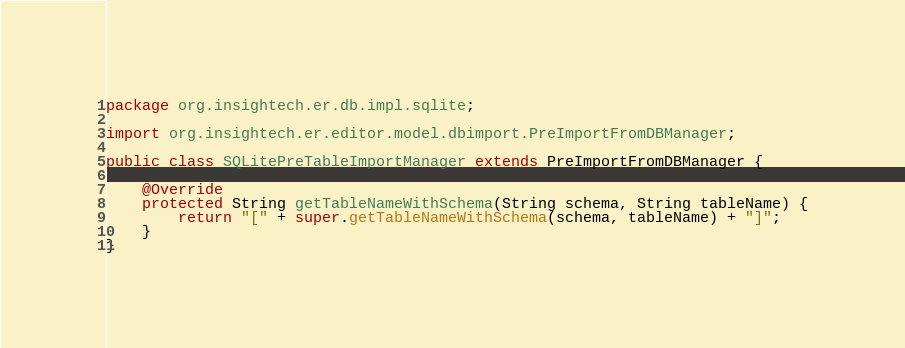Convert code to text. <code><loc_0><loc_0><loc_500><loc_500><_Java_>package org.insightech.er.db.impl.sqlite;

import org.insightech.er.editor.model.dbimport.PreImportFromDBManager;

public class SQLitePreTableImportManager extends PreImportFromDBManager {

	@Override
	protected String getTableNameWithSchema(String schema, String tableName) {
		return "[" + super.getTableNameWithSchema(schema, tableName) + "]";
	}
}
</code> 